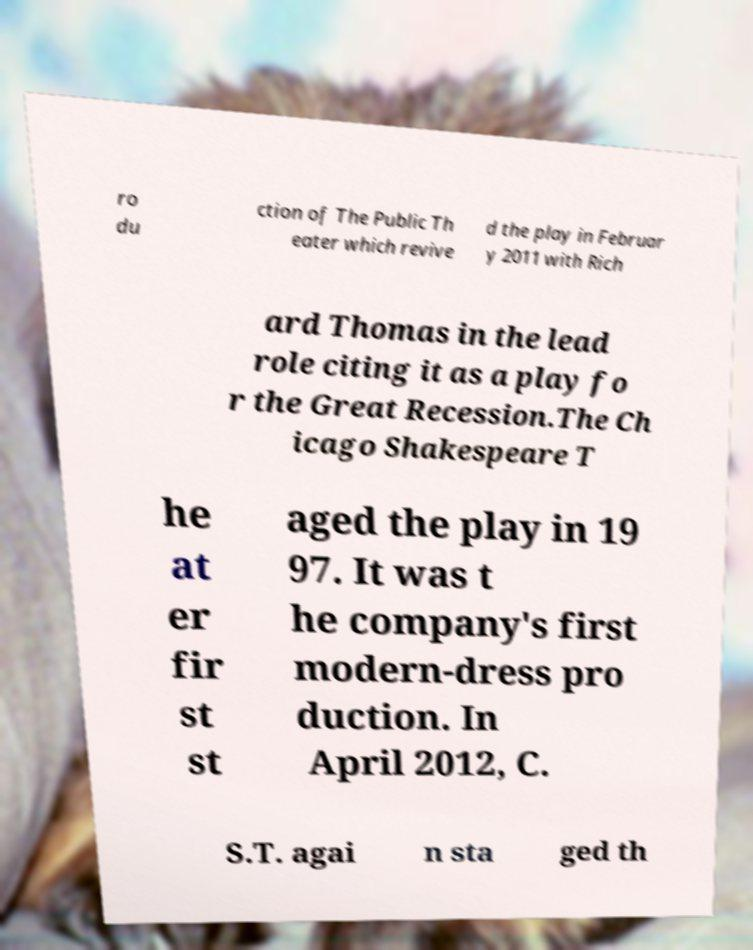For documentation purposes, I need the text within this image transcribed. Could you provide that? ro du ction of The Public Th eater which revive d the play in Februar y 2011 with Rich ard Thomas in the lead role citing it as a play fo r the Great Recession.The Ch icago Shakespeare T he at er fir st st aged the play in 19 97. It was t he company's first modern-dress pro duction. In April 2012, C. S.T. agai n sta ged th 